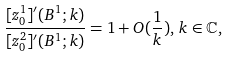Convert formula to latex. <formula><loc_0><loc_0><loc_500><loc_500>\frac { [ z _ { 0 } ^ { 1 } ] ^ { \prime } ( B ^ { 1 } ; k ) } { [ z _ { 0 } ^ { 2 } ] ^ { \prime } ( B ^ { 1 } ; k ) } = 1 + O ( \frac { 1 } { k } ) , \, k \in \mathbb { C } ,</formula> 